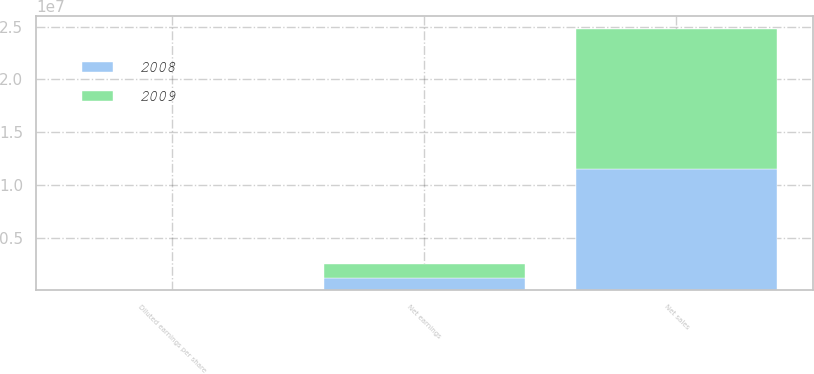<chart> <loc_0><loc_0><loc_500><loc_500><stacked_bar_chart><ecel><fcel>Net sales<fcel>Net earnings<fcel>Diluted earnings per share<nl><fcel>2008<fcel>1.14708e+07<fcel>1.1547e+06<fcel>3.47<nl><fcel>2009<fcel>1.33181e+07<fcel>1.31993e+06<fcel>3.96<nl></chart> 